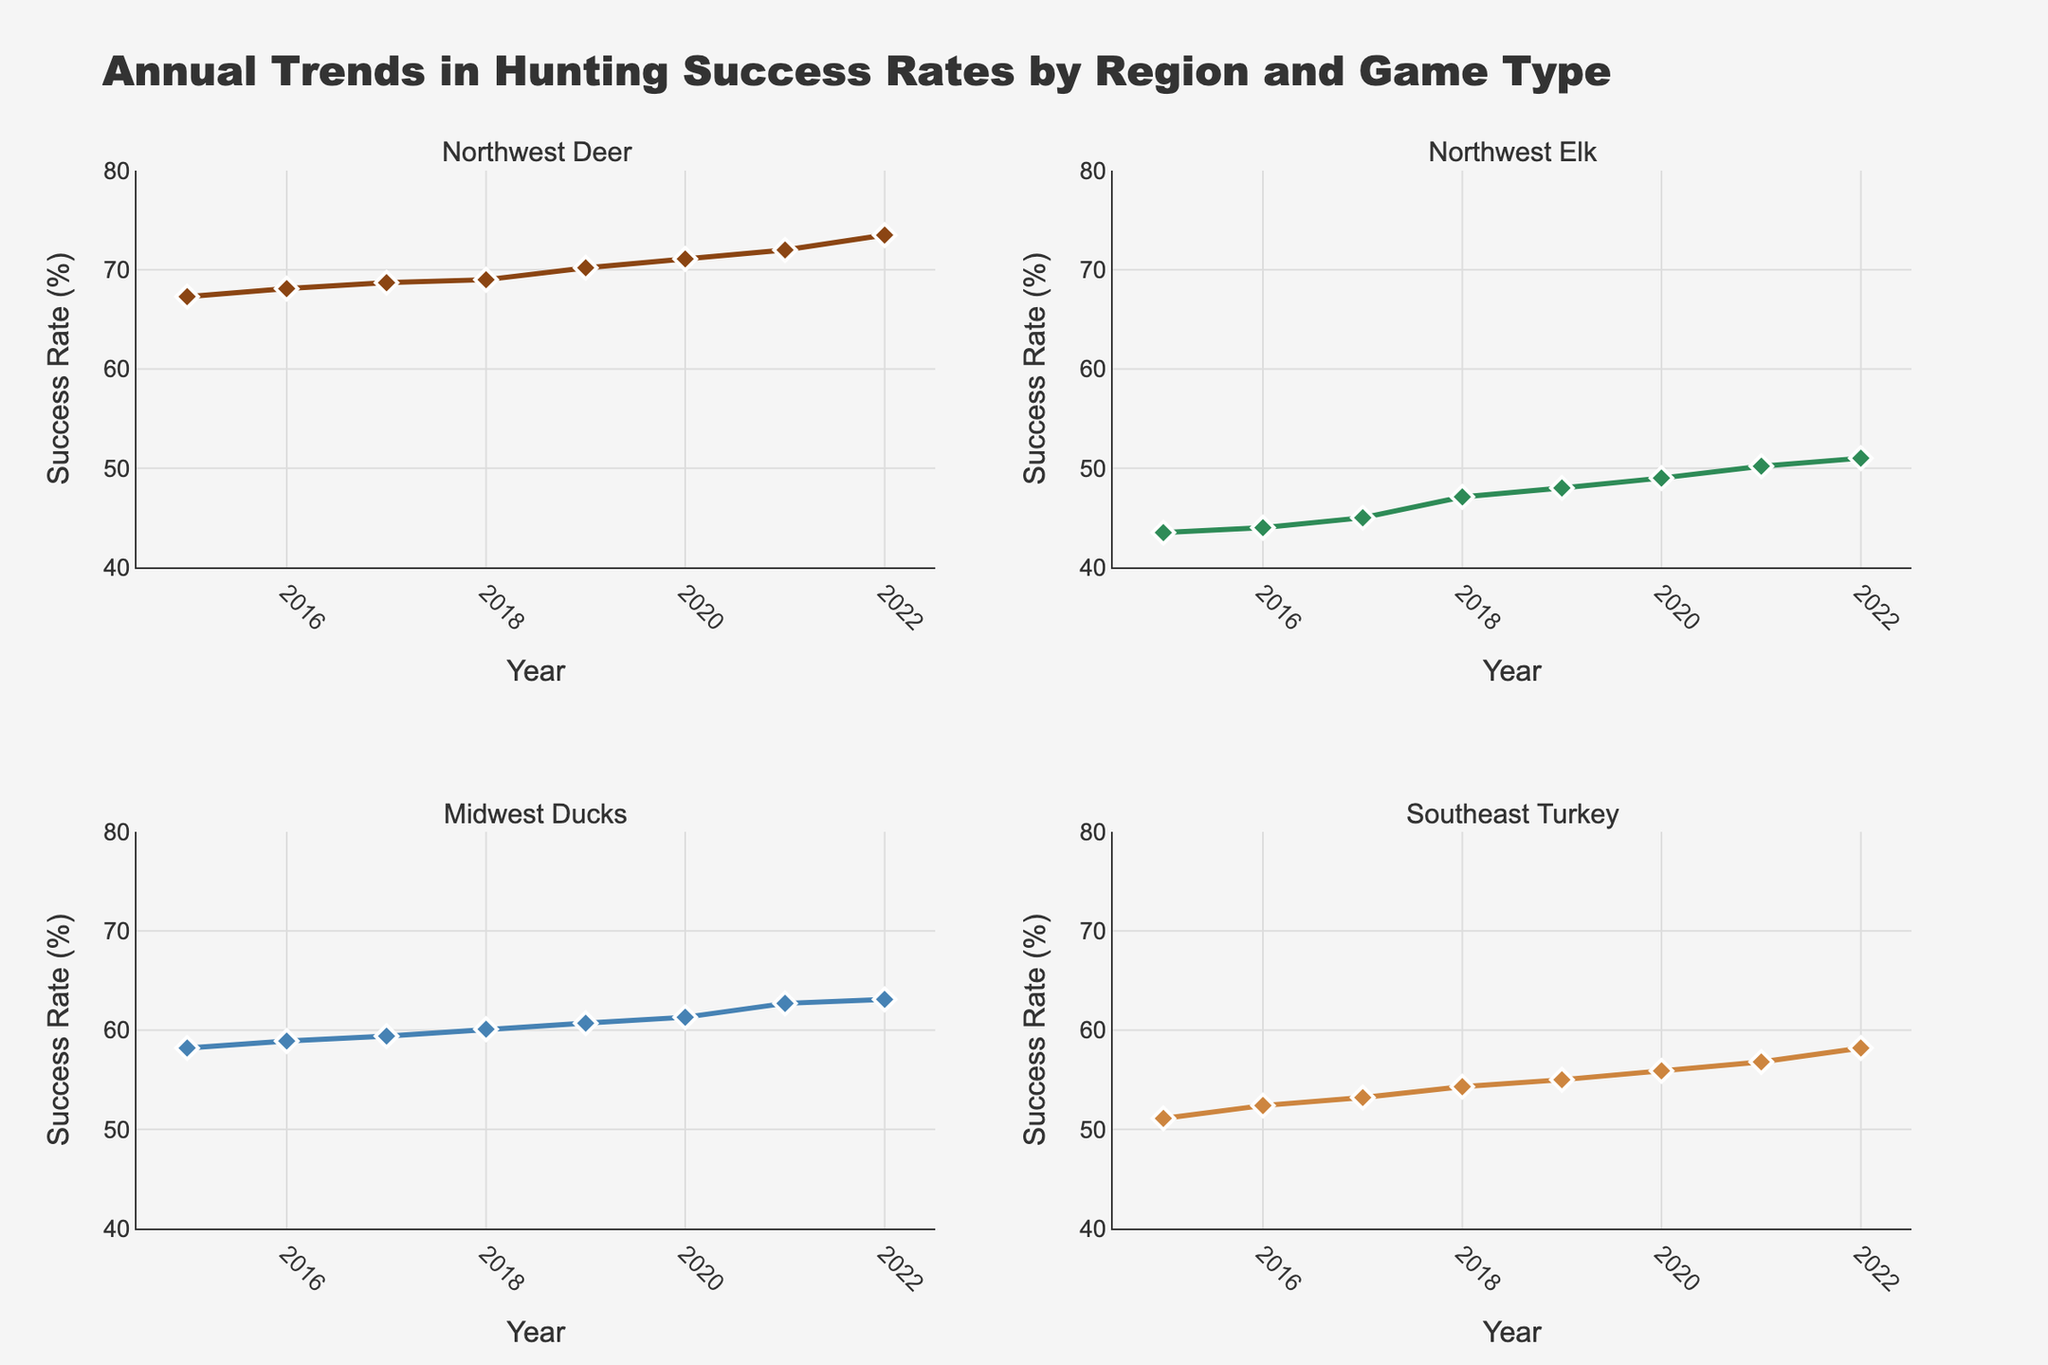Which region and game type has the highest success rate in 2022? Looking at the subplots, the "Northwest Deer" plot shows the highest value in 2022 with a success rate of 73.5%.
Answer: Northwest Deer How did the success rate for Southeast Turkey hunting change from 2015 to 2022? The success rate for Southeast Turkey increased from 51.1% in 2015 to 58.2% in 2022.
Answer: Increased from 51.1% to 58.2% Which game type in the Northwest shows a more significant increase in success rate from 2015 to 2022? Comparing the slopes of the lines in the Northwest plots, "Deer" shows a sharper increase from 67.3% to 73.5%, whereas "Elk" increases from 43.5% to 51.0% over the period.
Answer: Deer What is the average success rate for Midwest Ducks across all years shown? Sum the success rates for Midwest Ducks from 2015 to 2022: (58.2 + 58.9 + 59.4 + 60.1 + 60.7 + 61.3 + 62.7 + 63.1) = 484.4. Divide by the number of years (8): 484.4 / 8 = 60.55%.
Answer: 60.55% Did the success rate for Northwest Elk ever decrease from one year to the next? Examine the upward trend in the Northwest Elk subplot. From 2016 to 2017, the rate increased from 44.0% to 45.0%, thus there is no year with a decrease.
Answer: No Which year shows the highest overall success rate for any game type in any region? Examine all subplots. The highest overall success rate is in "Northwest Deer" in 2022 with a success rate of 73.5%.
Answer: 2022 Compare the success rate trend between Midwest Ducks and Southeast Turkey. Which has a more consistent increase over the years? Both trends are upward, but "Midwest Ducks" shows a more steady and less variable increase each year compared to "Southeast Turkey."
Answer: Midwest Ducks What was the success rate for Northwest Deer in 2019, and how much did it change by 2022? In the "Northwest Deer" subplot, the success rate in 2019 was 70.2%, and in 2022 it was 73.5%. The change is 73.5% - 70.2% = 3.3%.
Answer: 3.3% Which subplot shows the lowest starting success rate in 2015? Look at the initial points in all subplots: "Northwest Elk" begins at 43.5% in 2015, which is the lowest among all game types.
Answer: Northwest Elk (43.5%) 